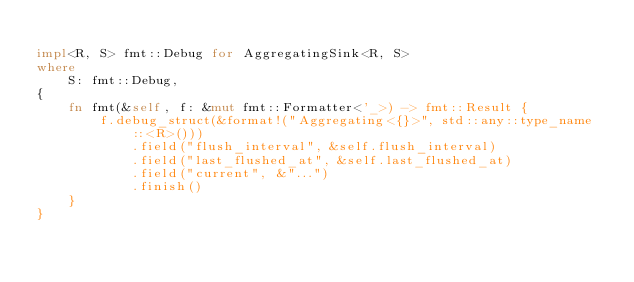Convert code to text. <code><loc_0><loc_0><loc_500><loc_500><_Rust_>
impl<R, S> fmt::Debug for AggregatingSink<R, S>
where
    S: fmt::Debug,
{
    fn fmt(&self, f: &mut fmt::Formatter<'_>) -> fmt::Result {
        f.debug_struct(&format!("Aggregating<{}>", std::any::type_name::<R>()))
            .field("flush_interval", &self.flush_interval)
            .field("last_flushed_at", &self.last_flushed_at)
            .field("current", &"...")
            .finish()
    }
}
</code> 